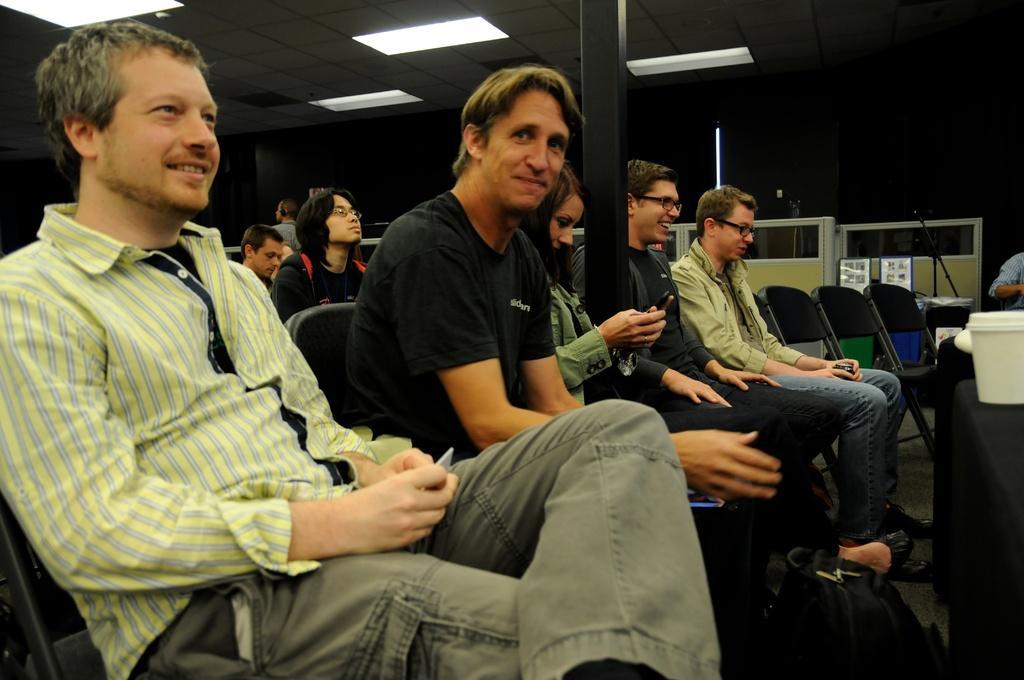Describe this image in one or two sentences. There are people sitting in the foreground area of the image, there are lamps, other objects and chairs in the background. 